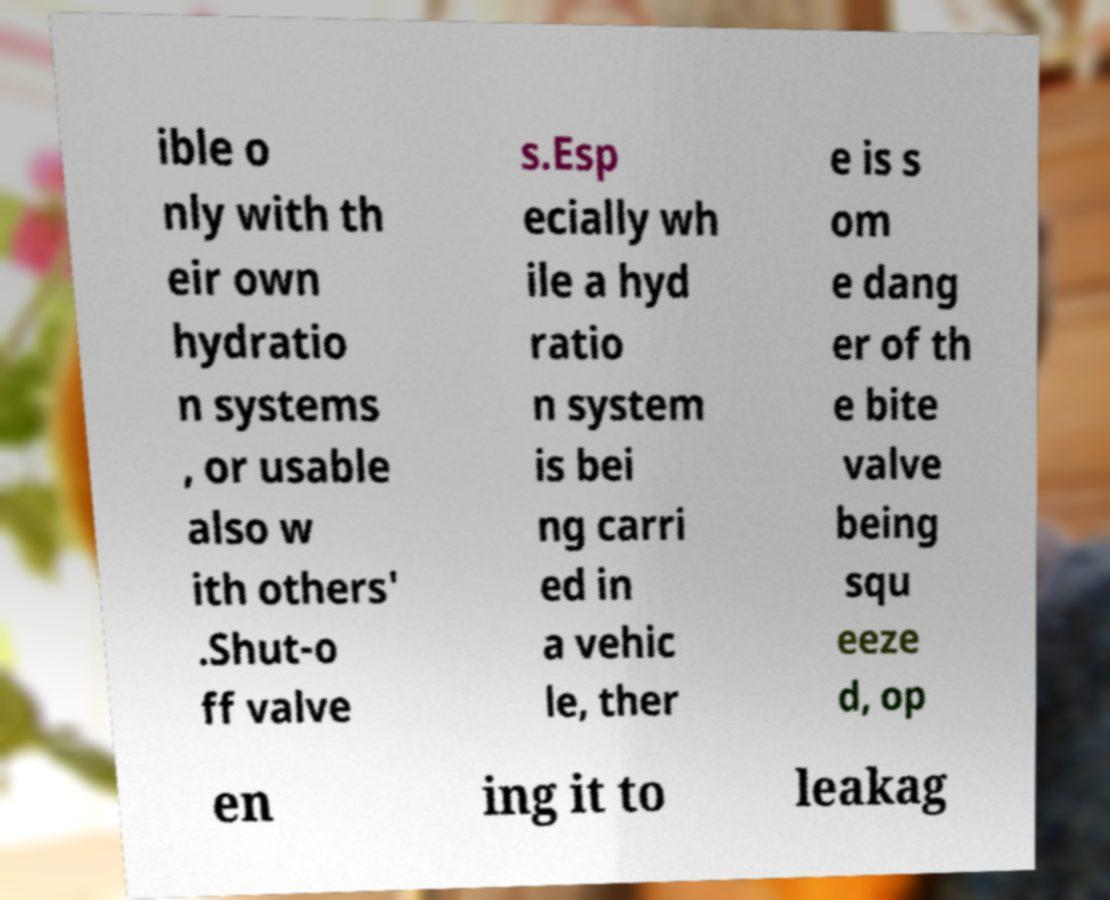For documentation purposes, I need the text within this image transcribed. Could you provide that? ible o nly with th eir own hydratio n systems , or usable also w ith others' .Shut-o ff valve s.Esp ecially wh ile a hyd ratio n system is bei ng carri ed in a vehic le, ther e is s om e dang er of th e bite valve being squ eeze d, op en ing it to leakag 